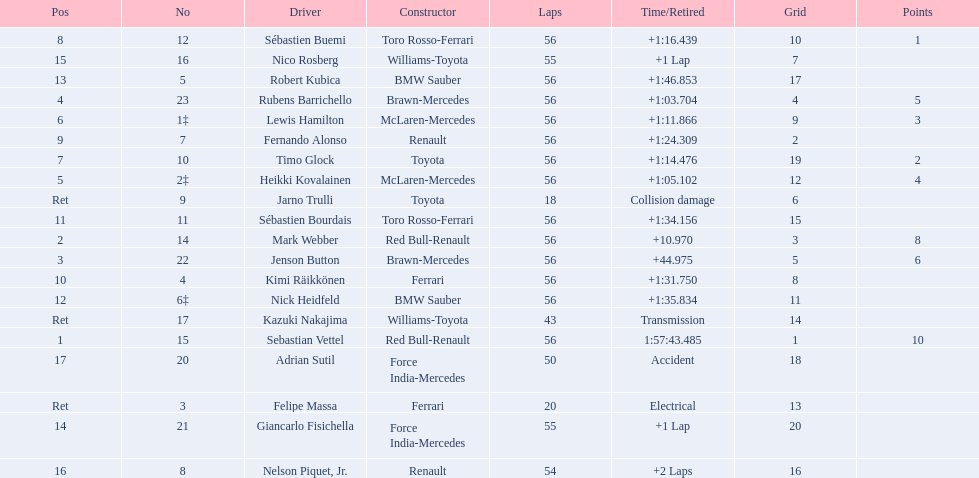Which drivers raced in the 2009 chinese grand prix? Sebastian Vettel, Mark Webber, Jenson Button, Rubens Barrichello, Heikki Kovalainen, Lewis Hamilton, Timo Glock, Sébastien Buemi, Fernando Alonso, Kimi Räikkönen, Sébastien Bourdais, Nick Heidfeld, Robert Kubica, Giancarlo Fisichella, Nico Rosberg, Nelson Piquet, Jr., Adrian Sutil, Kazuki Nakajima, Felipe Massa, Jarno Trulli. Of the drivers in the 2009 chinese grand prix, which finished the race? Sebastian Vettel, Mark Webber, Jenson Button, Rubens Barrichello, Heikki Kovalainen, Lewis Hamilton, Timo Glock, Sébastien Buemi, Fernando Alonso, Kimi Räikkönen, Sébastien Bourdais, Nick Heidfeld, Robert Kubica. Of the drivers who finished the race, who had the slowest time? Robert Kubica. 